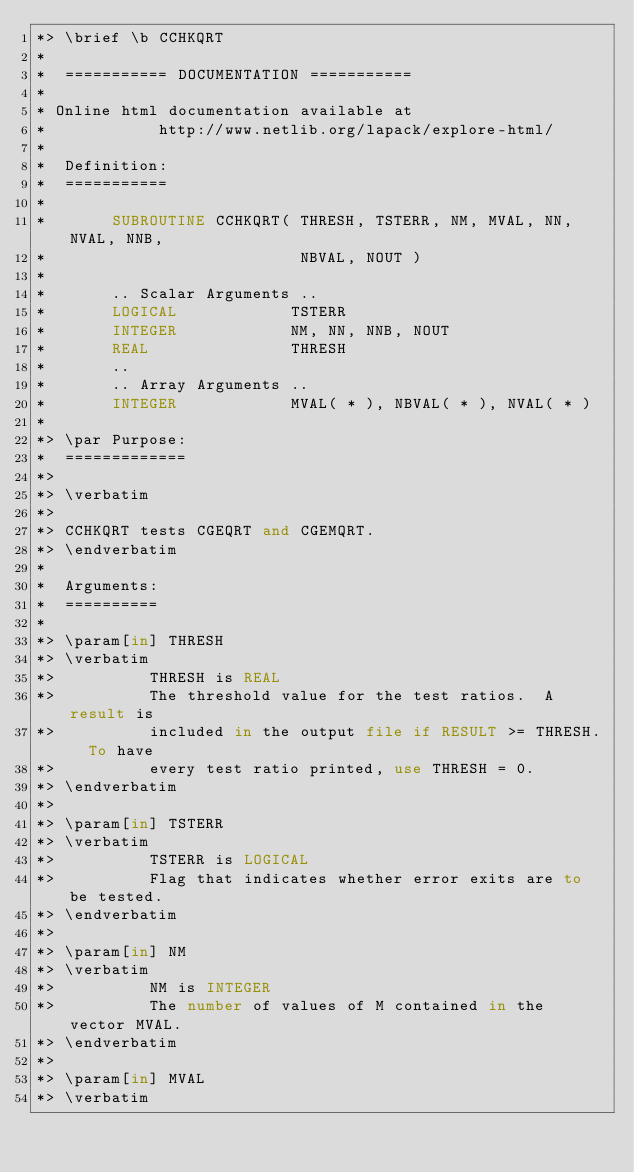Convert code to text. <code><loc_0><loc_0><loc_500><loc_500><_FORTRAN_>*> \brief \b CCHKQRT
*
*  =========== DOCUMENTATION ===========
*
* Online html documentation available at
*            http://www.netlib.org/lapack/explore-html/
*
*  Definition:
*  ===========
*
*       SUBROUTINE CCHKQRT( THRESH, TSTERR, NM, MVAL, NN, NVAL, NNB,
*                           NBVAL, NOUT )
*
*       .. Scalar Arguments ..
*       LOGICAL            TSTERR
*       INTEGER            NM, NN, NNB, NOUT
*       REAL               THRESH
*       ..
*       .. Array Arguments ..
*       INTEGER            MVAL( * ), NBVAL( * ), NVAL( * )
*
*> \par Purpose:
*  =============
*>
*> \verbatim
*>
*> CCHKQRT tests CGEQRT and CGEMQRT.
*> \endverbatim
*
*  Arguments:
*  ==========
*
*> \param[in] THRESH
*> \verbatim
*>          THRESH is REAL
*>          The threshold value for the test ratios.  A result is
*>          included in the output file if RESULT >= THRESH.  To have
*>          every test ratio printed, use THRESH = 0.
*> \endverbatim
*>
*> \param[in] TSTERR
*> \verbatim
*>          TSTERR is LOGICAL
*>          Flag that indicates whether error exits are to be tested.
*> \endverbatim
*>
*> \param[in] NM
*> \verbatim
*>          NM is INTEGER
*>          The number of values of M contained in the vector MVAL.
*> \endverbatim
*>
*> \param[in] MVAL
*> \verbatim</code> 